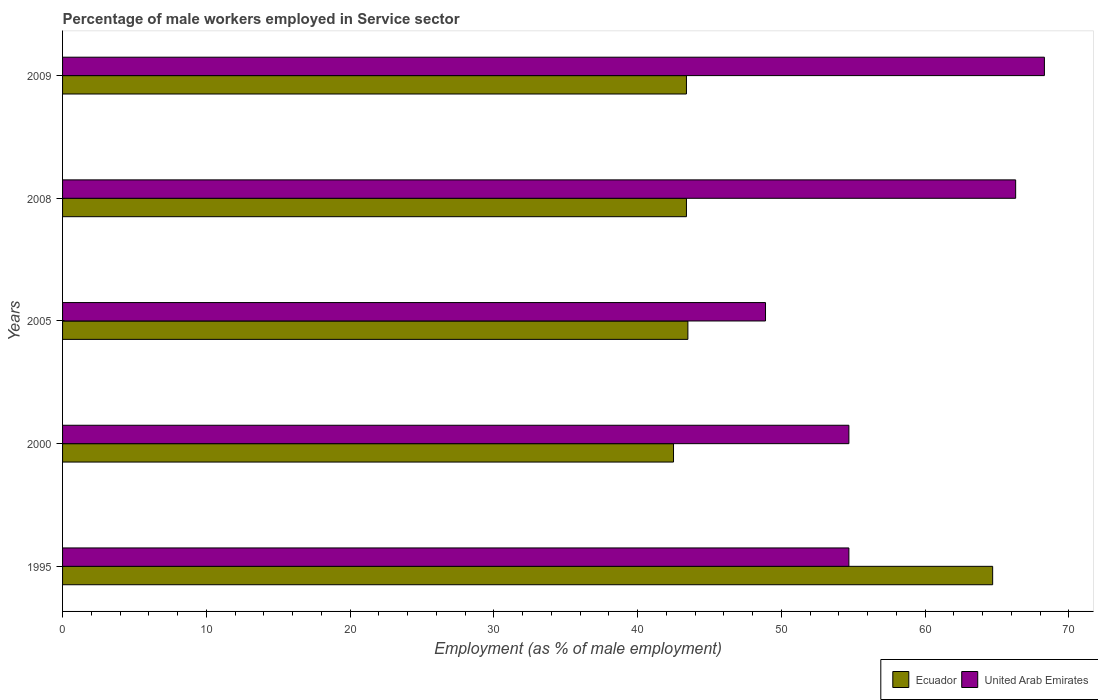Are the number of bars per tick equal to the number of legend labels?
Give a very brief answer. Yes. How many bars are there on the 2nd tick from the top?
Give a very brief answer. 2. What is the percentage of male workers employed in Service sector in United Arab Emirates in 1995?
Offer a very short reply. 54.7. Across all years, what is the maximum percentage of male workers employed in Service sector in United Arab Emirates?
Make the answer very short. 68.3. Across all years, what is the minimum percentage of male workers employed in Service sector in Ecuador?
Ensure brevity in your answer.  42.5. In which year was the percentage of male workers employed in Service sector in United Arab Emirates maximum?
Your answer should be compact. 2009. In which year was the percentage of male workers employed in Service sector in Ecuador minimum?
Your answer should be compact. 2000. What is the total percentage of male workers employed in Service sector in United Arab Emirates in the graph?
Give a very brief answer. 292.9. What is the difference between the percentage of male workers employed in Service sector in United Arab Emirates in 2005 and that in 2008?
Keep it short and to the point. -17.4. What is the difference between the percentage of male workers employed in Service sector in Ecuador in 2009 and the percentage of male workers employed in Service sector in United Arab Emirates in 2000?
Your answer should be very brief. -11.3. What is the average percentage of male workers employed in Service sector in United Arab Emirates per year?
Your answer should be compact. 58.58. In the year 1995, what is the difference between the percentage of male workers employed in Service sector in Ecuador and percentage of male workers employed in Service sector in United Arab Emirates?
Ensure brevity in your answer.  10. In how many years, is the percentage of male workers employed in Service sector in United Arab Emirates greater than 28 %?
Your answer should be very brief. 5. What is the ratio of the percentage of male workers employed in Service sector in United Arab Emirates in 2000 to that in 2009?
Provide a succinct answer. 0.8. What is the difference between the highest and the second highest percentage of male workers employed in Service sector in Ecuador?
Your answer should be very brief. 21.2. What is the difference between the highest and the lowest percentage of male workers employed in Service sector in United Arab Emirates?
Provide a short and direct response. 19.4. What does the 2nd bar from the top in 2009 represents?
Your answer should be very brief. Ecuador. What does the 1st bar from the bottom in 2008 represents?
Your answer should be compact. Ecuador. How many bars are there?
Your response must be concise. 10. What is the difference between two consecutive major ticks on the X-axis?
Give a very brief answer. 10. Are the values on the major ticks of X-axis written in scientific E-notation?
Keep it short and to the point. No. Does the graph contain any zero values?
Give a very brief answer. No. Does the graph contain grids?
Make the answer very short. No. What is the title of the graph?
Your response must be concise. Percentage of male workers employed in Service sector. Does "Nicaragua" appear as one of the legend labels in the graph?
Provide a succinct answer. No. What is the label or title of the X-axis?
Give a very brief answer. Employment (as % of male employment). What is the label or title of the Y-axis?
Provide a succinct answer. Years. What is the Employment (as % of male employment) of Ecuador in 1995?
Keep it short and to the point. 64.7. What is the Employment (as % of male employment) of United Arab Emirates in 1995?
Offer a very short reply. 54.7. What is the Employment (as % of male employment) in Ecuador in 2000?
Your answer should be compact. 42.5. What is the Employment (as % of male employment) in United Arab Emirates in 2000?
Your answer should be very brief. 54.7. What is the Employment (as % of male employment) of Ecuador in 2005?
Your answer should be very brief. 43.5. What is the Employment (as % of male employment) of United Arab Emirates in 2005?
Offer a terse response. 48.9. What is the Employment (as % of male employment) of Ecuador in 2008?
Provide a short and direct response. 43.4. What is the Employment (as % of male employment) in United Arab Emirates in 2008?
Your answer should be very brief. 66.3. What is the Employment (as % of male employment) of Ecuador in 2009?
Provide a short and direct response. 43.4. What is the Employment (as % of male employment) of United Arab Emirates in 2009?
Offer a very short reply. 68.3. Across all years, what is the maximum Employment (as % of male employment) of Ecuador?
Provide a succinct answer. 64.7. Across all years, what is the maximum Employment (as % of male employment) of United Arab Emirates?
Offer a very short reply. 68.3. Across all years, what is the minimum Employment (as % of male employment) of Ecuador?
Offer a terse response. 42.5. Across all years, what is the minimum Employment (as % of male employment) of United Arab Emirates?
Your answer should be compact. 48.9. What is the total Employment (as % of male employment) of Ecuador in the graph?
Provide a succinct answer. 237.5. What is the total Employment (as % of male employment) in United Arab Emirates in the graph?
Provide a succinct answer. 292.9. What is the difference between the Employment (as % of male employment) in Ecuador in 1995 and that in 2000?
Offer a terse response. 22.2. What is the difference between the Employment (as % of male employment) in United Arab Emirates in 1995 and that in 2000?
Keep it short and to the point. 0. What is the difference between the Employment (as % of male employment) of Ecuador in 1995 and that in 2005?
Ensure brevity in your answer.  21.2. What is the difference between the Employment (as % of male employment) of Ecuador in 1995 and that in 2008?
Ensure brevity in your answer.  21.3. What is the difference between the Employment (as % of male employment) in Ecuador in 1995 and that in 2009?
Ensure brevity in your answer.  21.3. What is the difference between the Employment (as % of male employment) of United Arab Emirates in 1995 and that in 2009?
Offer a terse response. -13.6. What is the difference between the Employment (as % of male employment) of United Arab Emirates in 2000 and that in 2005?
Your answer should be compact. 5.8. What is the difference between the Employment (as % of male employment) of Ecuador in 2000 and that in 2008?
Your answer should be compact. -0.9. What is the difference between the Employment (as % of male employment) of United Arab Emirates in 2000 and that in 2008?
Your answer should be very brief. -11.6. What is the difference between the Employment (as % of male employment) in Ecuador in 2000 and that in 2009?
Offer a very short reply. -0.9. What is the difference between the Employment (as % of male employment) in United Arab Emirates in 2005 and that in 2008?
Provide a short and direct response. -17.4. What is the difference between the Employment (as % of male employment) in United Arab Emirates in 2005 and that in 2009?
Give a very brief answer. -19.4. What is the difference between the Employment (as % of male employment) of Ecuador in 2008 and that in 2009?
Offer a very short reply. 0. What is the difference between the Employment (as % of male employment) of Ecuador in 1995 and the Employment (as % of male employment) of United Arab Emirates in 2000?
Offer a terse response. 10. What is the difference between the Employment (as % of male employment) of Ecuador in 1995 and the Employment (as % of male employment) of United Arab Emirates in 2008?
Keep it short and to the point. -1.6. What is the difference between the Employment (as % of male employment) in Ecuador in 2000 and the Employment (as % of male employment) in United Arab Emirates in 2008?
Offer a very short reply. -23.8. What is the difference between the Employment (as % of male employment) of Ecuador in 2000 and the Employment (as % of male employment) of United Arab Emirates in 2009?
Your response must be concise. -25.8. What is the difference between the Employment (as % of male employment) of Ecuador in 2005 and the Employment (as % of male employment) of United Arab Emirates in 2008?
Make the answer very short. -22.8. What is the difference between the Employment (as % of male employment) of Ecuador in 2005 and the Employment (as % of male employment) of United Arab Emirates in 2009?
Offer a very short reply. -24.8. What is the difference between the Employment (as % of male employment) in Ecuador in 2008 and the Employment (as % of male employment) in United Arab Emirates in 2009?
Keep it short and to the point. -24.9. What is the average Employment (as % of male employment) in Ecuador per year?
Provide a succinct answer. 47.5. What is the average Employment (as % of male employment) of United Arab Emirates per year?
Provide a succinct answer. 58.58. In the year 2000, what is the difference between the Employment (as % of male employment) of Ecuador and Employment (as % of male employment) of United Arab Emirates?
Provide a short and direct response. -12.2. In the year 2008, what is the difference between the Employment (as % of male employment) in Ecuador and Employment (as % of male employment) in United Arab Emirates?
Your response must be concise. -22.9. In the year 2009, what is the difference between the Employment (as % of male employment) in Ecuador and Employment (as % of male employment) in United Arab Emirates?
Make the answer very short. -24.9. What is the ratio of the Employment (as % of male employment) of Ecuador in 1995 to that in 2000?
Give a very brief answer. 1.52. What is the ratio of the Employment (as % of male employment) in Ecuador in 1995 to that in 2005?
Offer a terse response. 1.49. What is the ratio of the Employment (as % of male employment) in United Arab Emirates in 1995 to that in 2005?
Offer a terse response. 1.12. What is the ratio of the Employment (as % of male employment) in Ecuador in 1995 to that in 2008?
Your answer should be very brief. 1.49. What is the ratio of the Employment (as % of male employment) in United Arab Emirates in 1995 to that in 2008?
Keep it short and to the point. 0.82. What is the ratio of the Employment (as % of male employment) in Ecuador in 1995 to that in 2009?
Ensure brevity in your answer.  1.49. What is the ratio of the Employment (as % of male employment) in United Arab Emirates in 1995 to that in 2009?
Ensure brevity in your answer.  0.8. What is the ratio of the Employment (as % of male employment) in Ecuador in 2000 to that in 2005?
Give a very brief answer. 0.98. What is the ratio of the Employment (as % of male employment) in United Arab Emirates in 2000 to that in 2005?
Provide a succinct answer. 1.12. What is the ratio of the Employment (as % of male employment) of Ecuador in 2000 to that in 2008?
Provide a succinct answer. 0.98. What is the ratio of the Employment (as % of male employment) of United Arab Emirates in 2000 to that in 2008?
Provide a short and direct response. 0.82. What is the ratio of the Employment (as % of male employment) in Ecuador in 2000 to that in 2009?
Your answer should be compact. 0.98. What is the ratio of the Employment (as % of male employment) of United Arab Emirates in 2000 to that in 2009?
Your response must be concise. 0.8. What is the ratio of the Employment (as % of male employment) of United Arab Emirates in 2005 to that in 2008?
Your answer should be very brief. 0.74. What is the ratio of the Employment (as % of male employment) in Ecuador in 2005 to that in 2009?
Offer a very short reply. 1. What is the ratio of the Employment (as % of male employment) in United Arab Emirates in 2005 to that in 2009?
Provide a short and direct response. 0.72. What is the ratio of the Employment (as % of male employment) of Ecuador in 2008 to that in 2009?
Give a very brief answer. 1. What is the ratio of the Employment (as % of male employment) of United Arab Emirates in 2008 to that in 2009?
Keep it short and to the point. 0.97. What is the difference between the highest and the second highest Employment (as % of male employment) in Ecuador?
Ensure brevity in your answer.  21.2. 